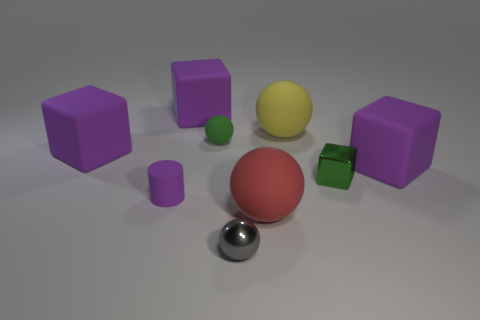Subtract all yellow spheres. How many purple cubes are left? 3 Subtract 1 cubes. How many cubes are left? 3 Subtract all purple spheres. Subtract all green cylinders. How many spheres are left? 4 Subtract all blocks. How many objects are left? 5 Subtract all green rubber things. Subtract all tiny matte objects. How many objects are left? 6 Add 8 green objects. How many green objects are left? 10 Add 6 big red rubber things. How many big red rubber things exist? 7 Subtract 0 yellow cubes. How many objects are left? 9 